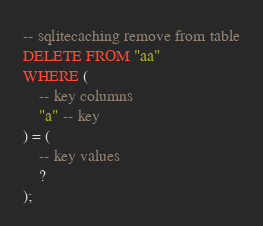<code> <loc_0><loc_0><loc_500><loc_500><_SQL_>-- sqlitecaching remove from table
DELETE FROM "aa"
WHERE (
    -- key columns
    "a" -- key
) = (
    -- key values
    ?
);
</code> 